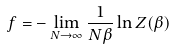<formula> <loc_0><loc_0><loc_500><loc_500>f = - \lim _ { N \rightarrow \infty } \frac { 1 } { N \beta } \ln Z ( \beta )</formula> 